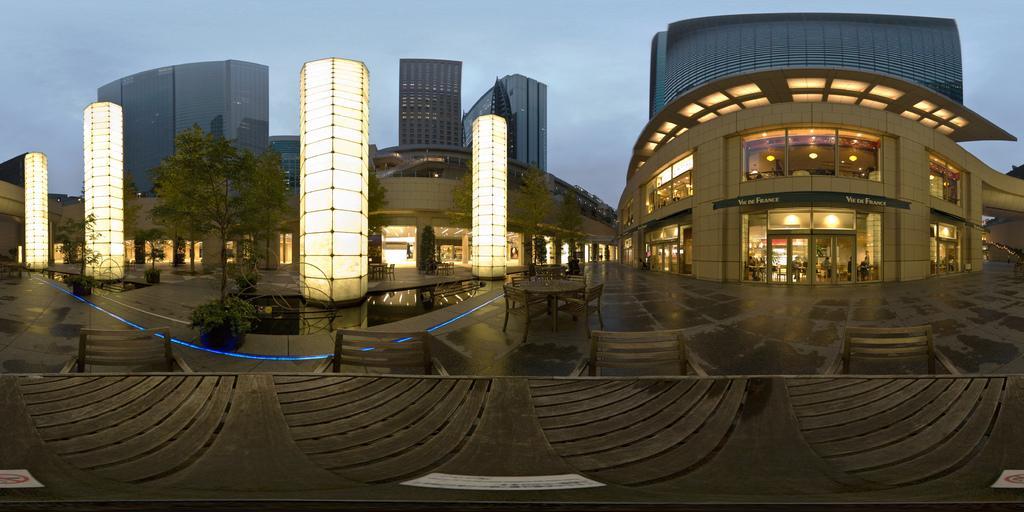How would you summarize this image in a sentence or two? In this image we can see some buildings, windows, doors, lights, there are some benches, chairs, trees, plants, also we can see the water, and the sky. 